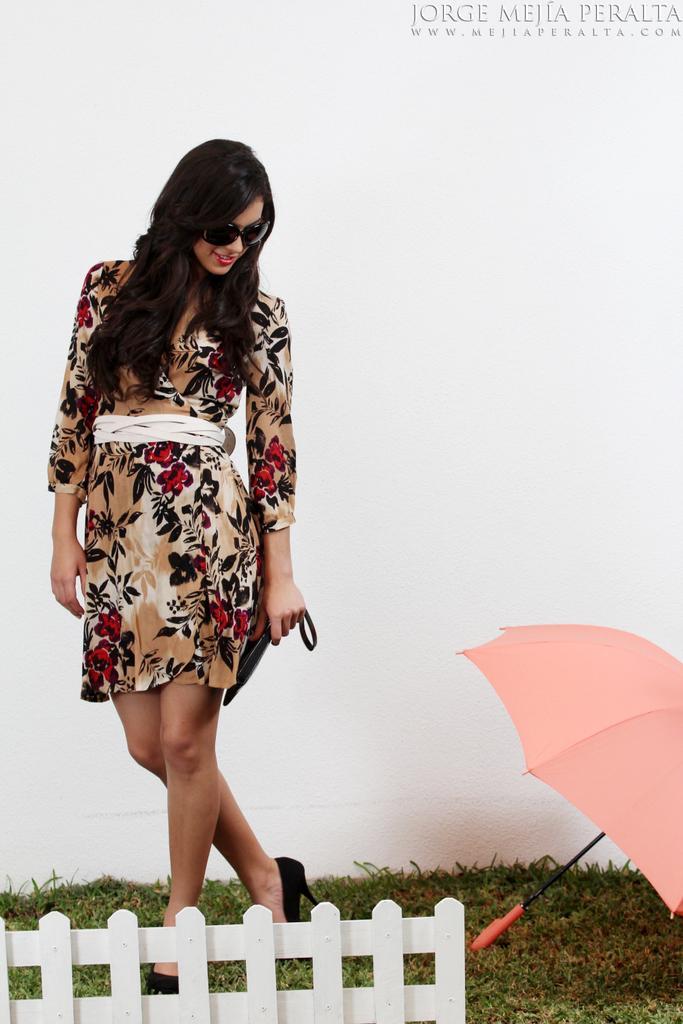Describe this image in one or two sentences. In this image I can see a woman is standing. I can see she is wearing shades and I can also see smile on her face. Here I can see she is holding a black colour thing. I can also see grass, a pink colour umbrella and white colour wall. 